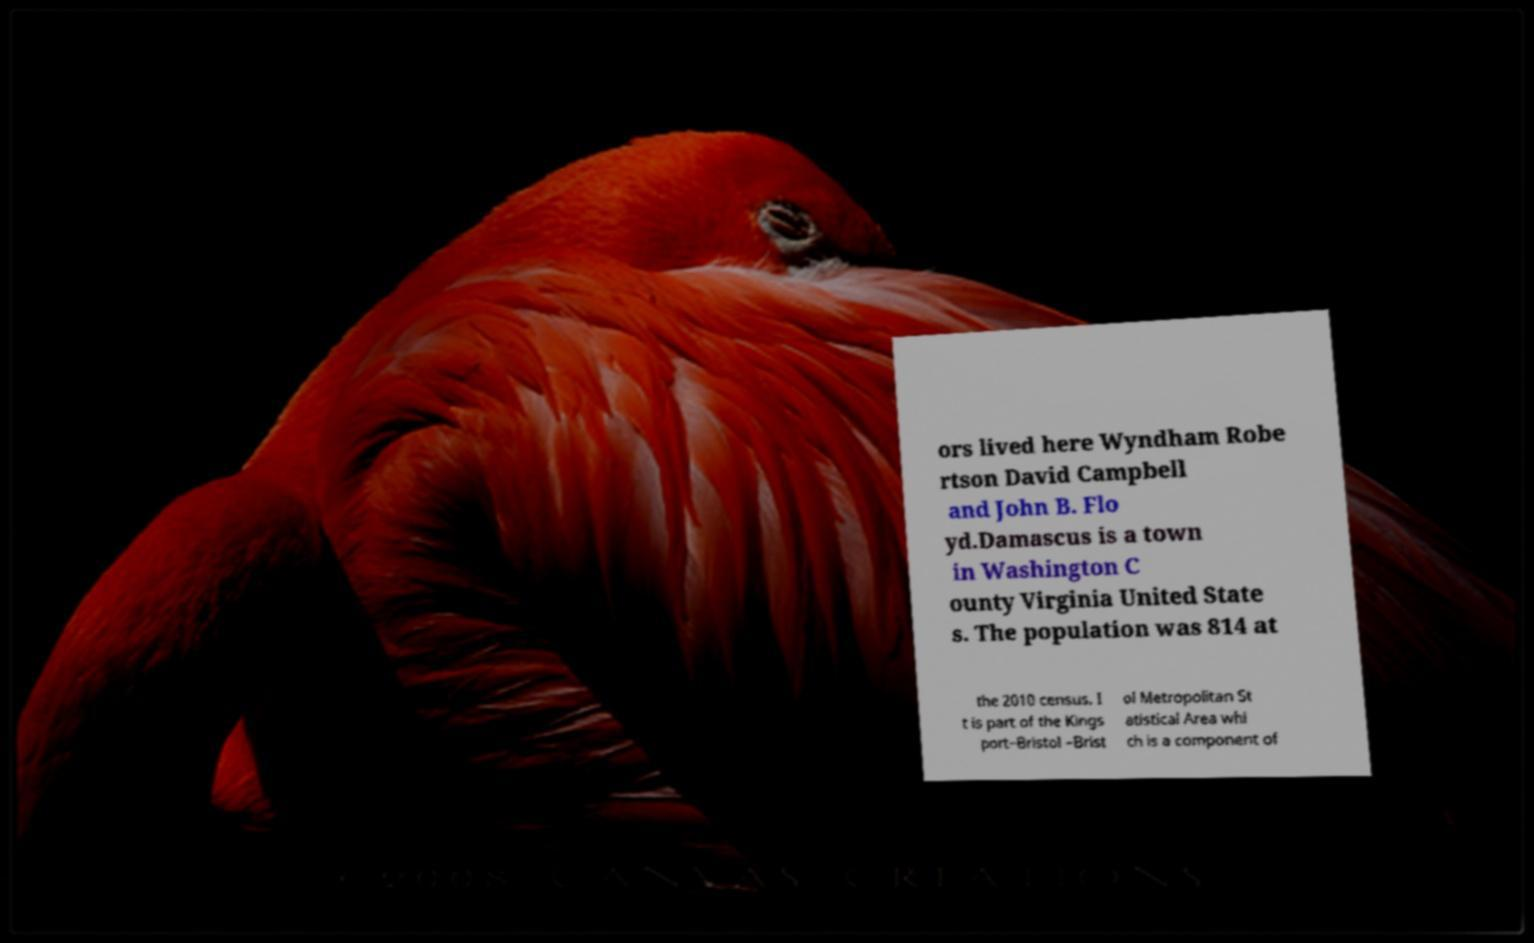For documentation purposes, I need the text within this image transcribed. Could you provide that? ors lived here Wyndham Robe rtson David Campbell and John B. Flo yd.Damascus is a town in Washington C ounty Virginia United State s. The population was 814 at the 2010 census. I t is part of the Kings port–Bristol –Brist ol Metropolitan St atistical Area whi ch is a component of 